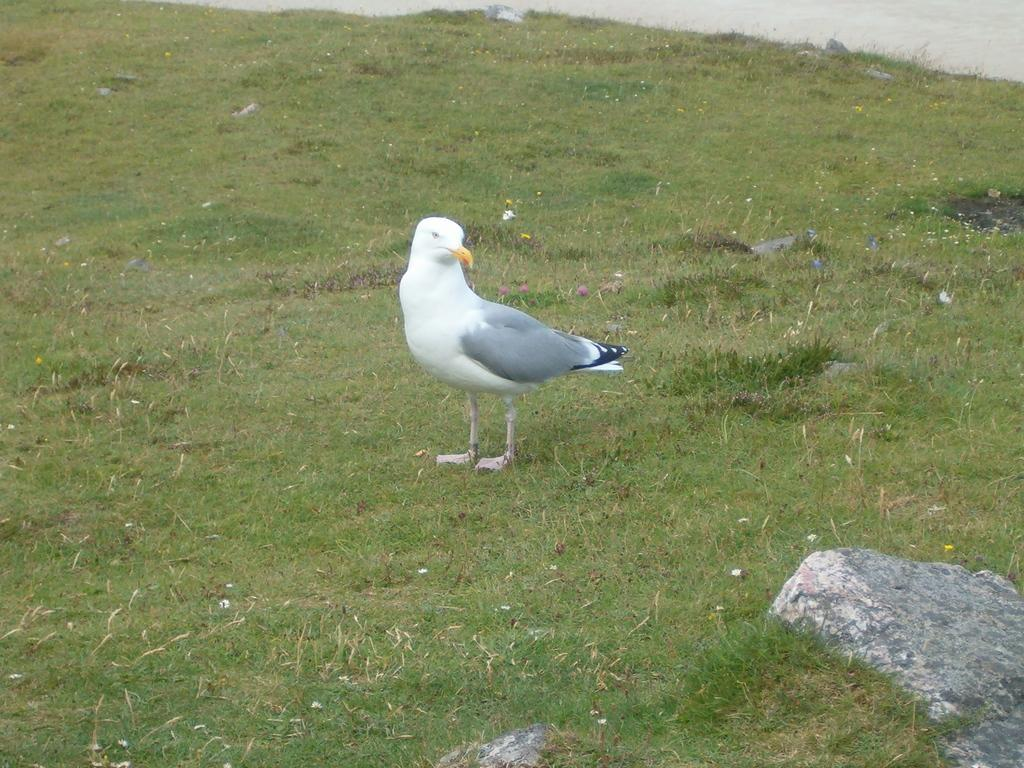What type of animal is in the image? There is a bird in the image. Where is the bird located? The bird is standing on the grass. Can you describe any other objects in the image? There is a stone in the bottom right corner of the image. How many sisters does the bird have in the image? There are no sisters mentioned or depicted in the image, as it features a bird standing on the grass and a stone in the corner. 